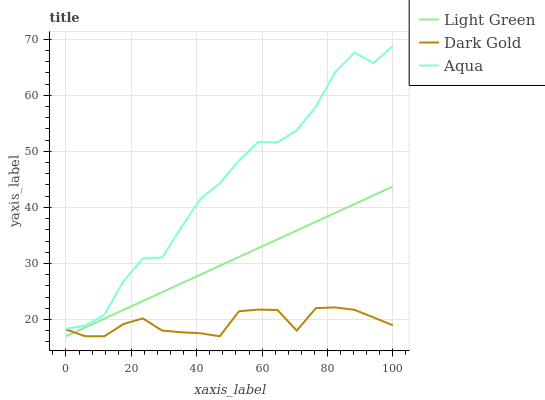Does Dark Gold have the minimum area under the curve?
Answer yes or no. Yes. Does Aqua have the maximum area under the curve?
Answer yes or no. Yes. Does Light Green have the minimum area under the curve?
Answer yes or no. No. Does Light Green have the maximum area under the curve?
Answer yes or no. No. Is Light Green the smoothest?
Answer yes or no. Yes. Is Aqua the roughest?
Answer yes or no. Yes. Is Dark Gold the smoothest?
Answer yes or no. No. Is Dark Gold the roughest?
Answer yes or no. No. Does Light Green have the lowest value?
Answer yes or no. Yes. Does Aqua have the highest value?
Answer yes or no. Yes. Does Light Green have the highest value?
Answer yes or no. No. Is Light Green less than Aqua?
Answer yes or no. Yes. Is Aqua greater than Light Green?
Answer yes or no. Yes. Does Dark Gold intersect Light Green?
Answer yes or no. Yes. Is Dark Gold less than Light Green?
Answer yes or no. No. Is Dark Gold greater than Light Green?
Answer yes or no. No. Does Light Green intersect Aqua?
Answer yes or no. No. 